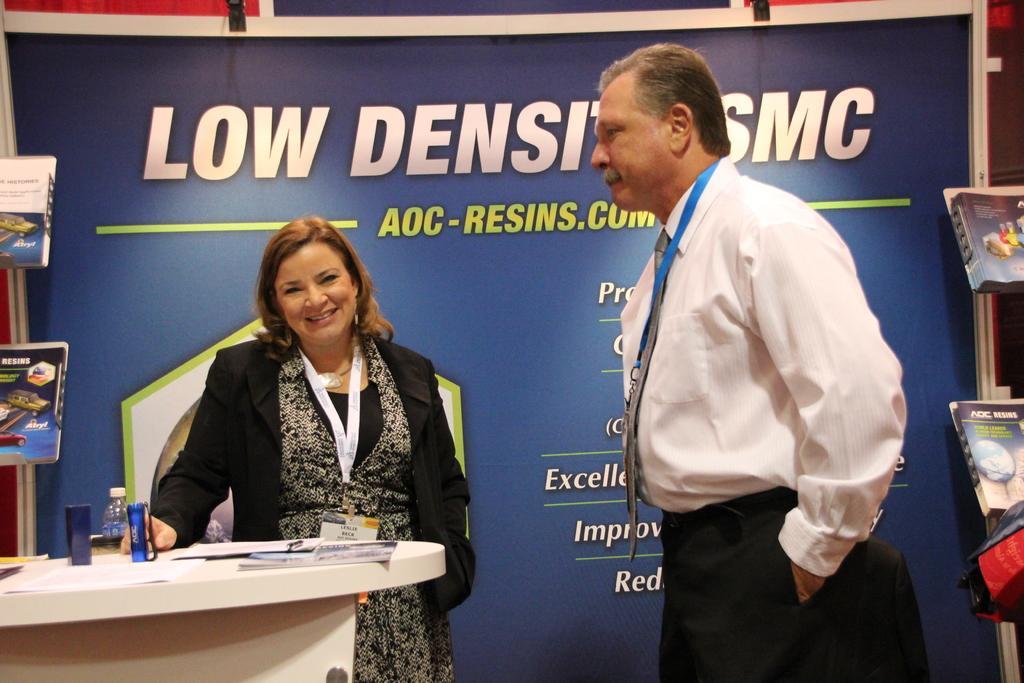How would you summarize this image in a sentence or two? In this image there is a woman standing wearing a ID card , another man standing beside the woman , and at the back ground there are books in the rack , hoarding, and in table there are paper, bottle, box. 